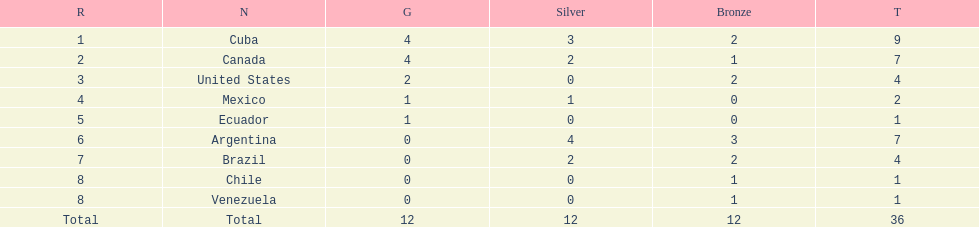Which is the only nation to win a gold medal and nothing else? Ecuador. 